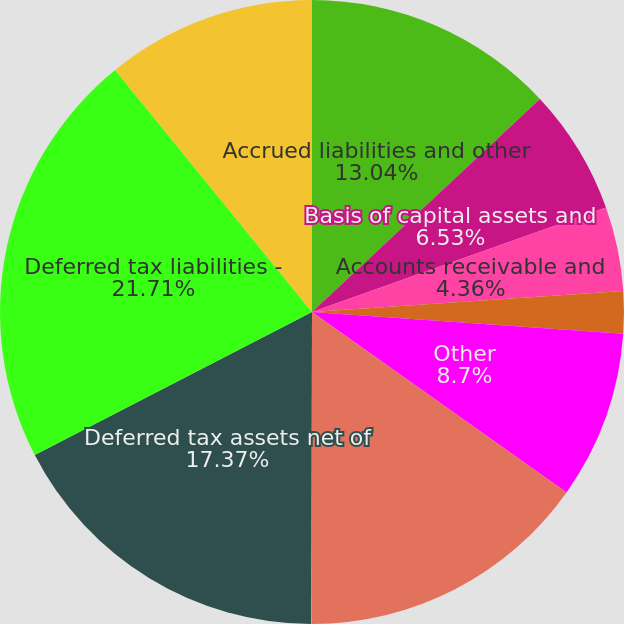Convert chart to OTSL. <chart><loc_0><loc_0><loc_500><loc_500><pie_chart><fcel>Accrued liabilities and other<fcel>Basis of capital assets and<fcel>Accounts receivable and<fcel>Stock-based compensation<fcel>Other<fcel>Total deferred tax assets<fcel>Less valuation allowance<fcel>Deferred tax assets net of<fcel>Deferred tax liabilities -<fcel>Net deferred tax liabilities<nl><fcel>13.04%<fcel>6.53%<fcel>4.36%<fcel>2.19%<fcel>8.7%<fcel>15.21%<fcel>0.02%<fcel>17.38%<fcel>21.72%<fcel>10.87%<nl></chart> 